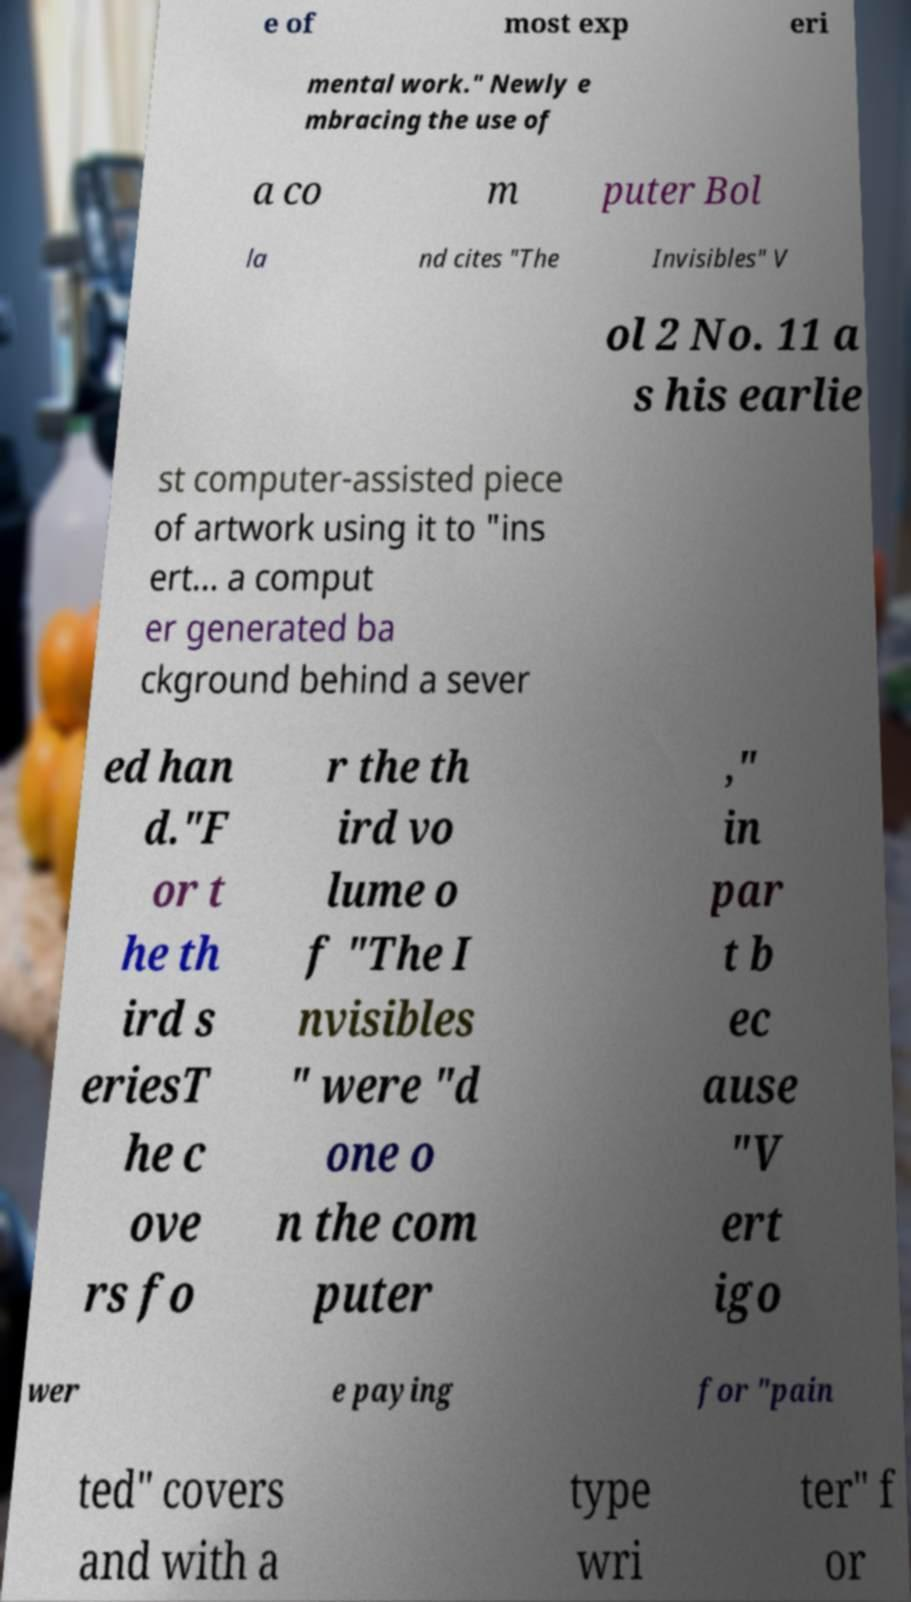Please identify and transcribe the text found in this image. e of most exp eri mental work." Newly e mbracing the use of a co m puter Bol la nd cites "The Invisibles" V ol 2 No. 11 a s his earlie st computer-assisted piece of artwork using it to "ins ert... a comput er generated ba ckground behind a sever ed han d."F or t he th ird s eriesT he c ove rs fo r the th ird vo lume o f "The I nvisibles " were "d one o n the com puter ," in par t b ec ause "V ert igo wer e paying for "pain ted" covers and with a type wri ter" f or 